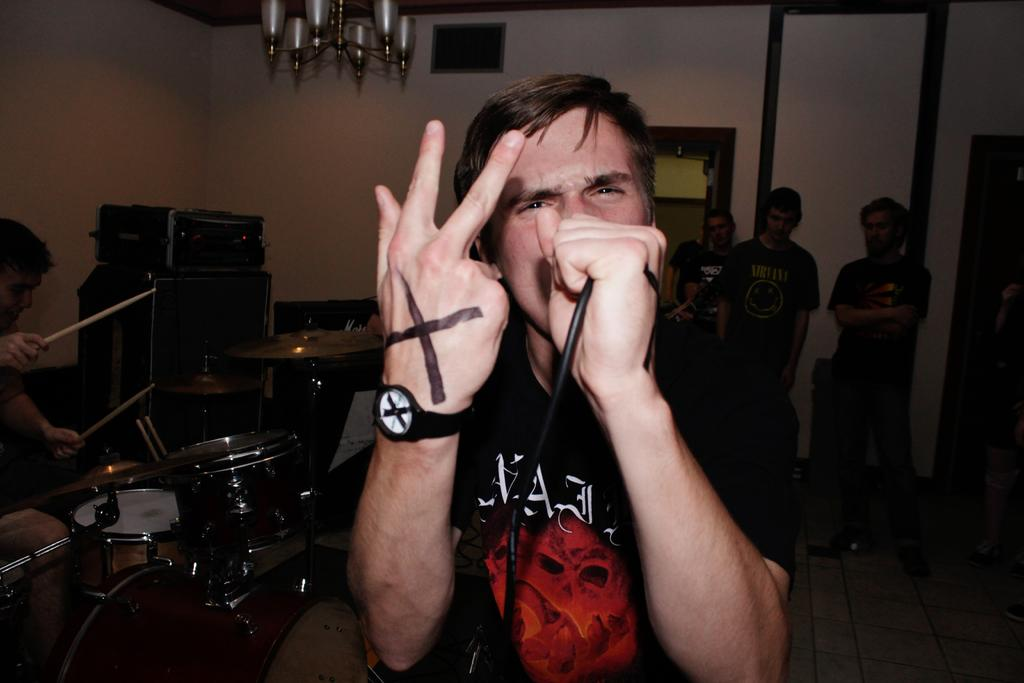What is the man in the center of the image holding? The man is holding a microphone in the image. What instrument is being played on the left side of the image? There is a man playing drums on the left side of the image. What can be seen on the right side of the image? There are people standing on the right side of the image. Is there a campfire with smoke visible in the image? No, there is no campfire or smoke present in the image. What type of hammer is being used by the man playing drums? The man playing drums is not using a hammer; he is using drumsticks to play the drums. 